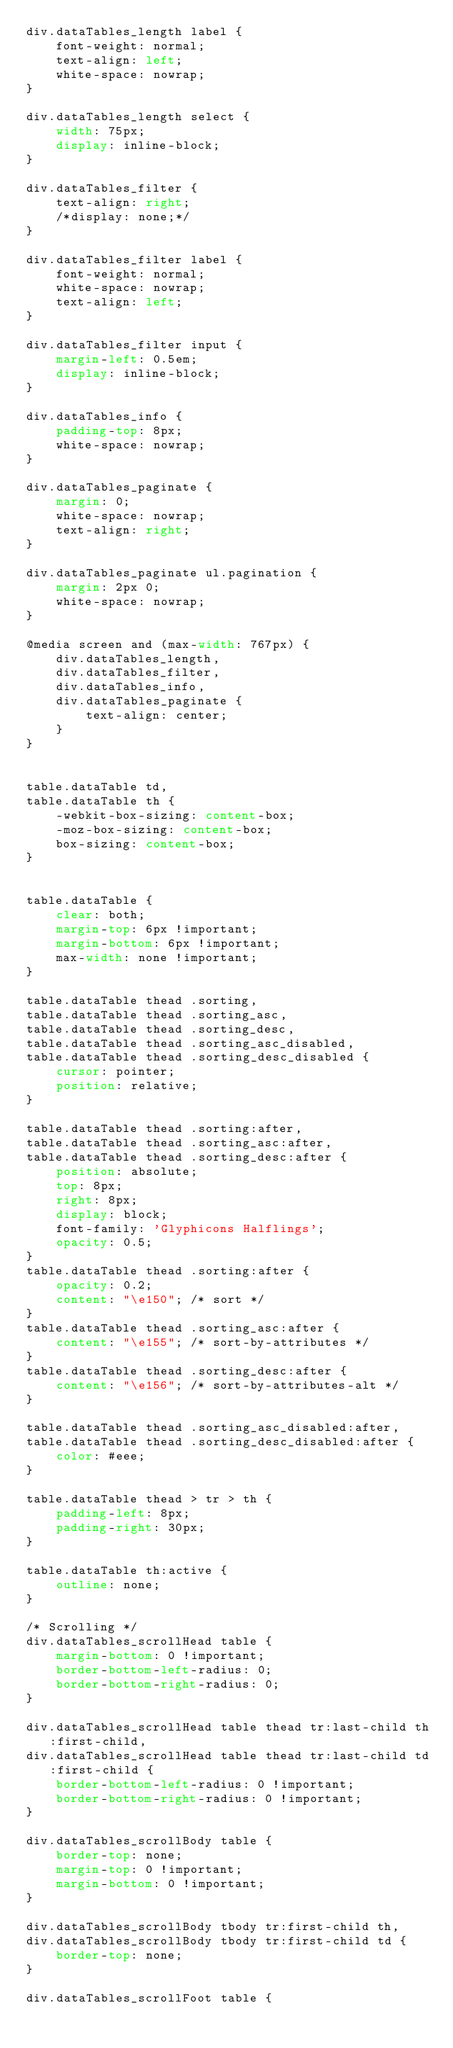Convert code to text. <code><loc_0><loc_0><loc_500><loc_500><_CSS_>div.dataTables_length label {
	font-weight: normal;
	text-align: left;
	white-space: nowrap;
}

div.dataTables_length select {
	width: 75px;
	display: inline-block;
}

div.dataTables_filter {
	text-align: right;
	/*display: none;*/
}

div.dataTables_filter label {
	font-weight: normal;
	white-space: nowrap;
	text-align: left;
}

div.dataTables_filter input {
	margin-left: 0.5em;
	display: inline-block;
}

div.dataTables_info {
	padding-top: 8px;
	white-space: nowrap;
}

div.dataTables_paginate {
	margin: 0;
	white-space: nowrap;
	text-align: right;
}

div.dataTables_paginate ul.pagination {
	margin: 2px 0;
	white-space: nowrap;
}

@media screen and (max-width: 767px) {
	div.dataTables_length,
	div.dataTables_filter,
	div.dataTables_info,
	div.dataTables_paginate {
		text-align: center;
	}
}


table.dataTable td,
table.dataTable th {
	-webkit-box-sizing: content-box;
	-moz-box-sizing: content-box;
	box-sizing: content-box;
}


table.dataTable {
	clear: both;
	margin-top: 6px !important;
	margin-bottom: 6px !important;
	max-width: none !important;
}

table.dataTable thead .sorting,
table.dataTable thead .sorting_asc,
table.dataTable thead .sorting_desc,
table.dataTable thead .sorting_asc_disabled,
table.dataTable thead .sorting_desc_disabled {
	cursor: pointer;
	position: relative;
}

table.dataTable thead .sorting:after,
table.dataTable thead .sorting_asc:after,
table.dataTable thead .sorting_desc:after {
	position: absolute;
	top: 8px;
	right: 8px;
	display: block;
	font-family: 'Glyphicons Halflings';
	opacity: 0.5;
}
table.dataTable thead .sorting:after {
	opacity: 0.2;
	content: "\e150"; /* sort */
}
table.dataTable thead .sorting_asc:after {
	content: "\e155"; /* sort-by-attributes */
}
table.dataTable thead .sorting_desc:after {
	content: "\e156"; /* sort-by-attributes-alt */
}

table.dataTable thead .sorting_asc_disabled:after,
table.dataTable thead .sorting_desc_disabled:after {
	color: #eee;
}

table.dataTable thead > tr > th {
	padding-left: 8px;
	padding-right: 30px;
}

table.dataTable th:active {
	outline: none;
}

/* Scrolling */
div.dataTables_scrollHead table {
	margin-bottom: 0 !important;
	border-bottom-left-radius: 0;
	border-bottom-right-radius: 0;
}

div.dataTables_scrollHead table thead tr:last-child th:first-child,
div.dataTables_scrollHead table thead tr:last-child td:first-child {
	border-bottom-left-radius: 0 !important;
	border-bottom-right-radius: 0 !important;
}

div.dataTables_scrollBody table {
	border-top: none;
	margin-top: 0 !important;
	margin-bottom: 0 !important;
}

div.dataTables_scrollBody tbody tr:first-child th,
div.dataTables_scrollBody tbody tr:first-child td {
	border-top: none;
}

div.dataTables_scrollFoot table {</code> 